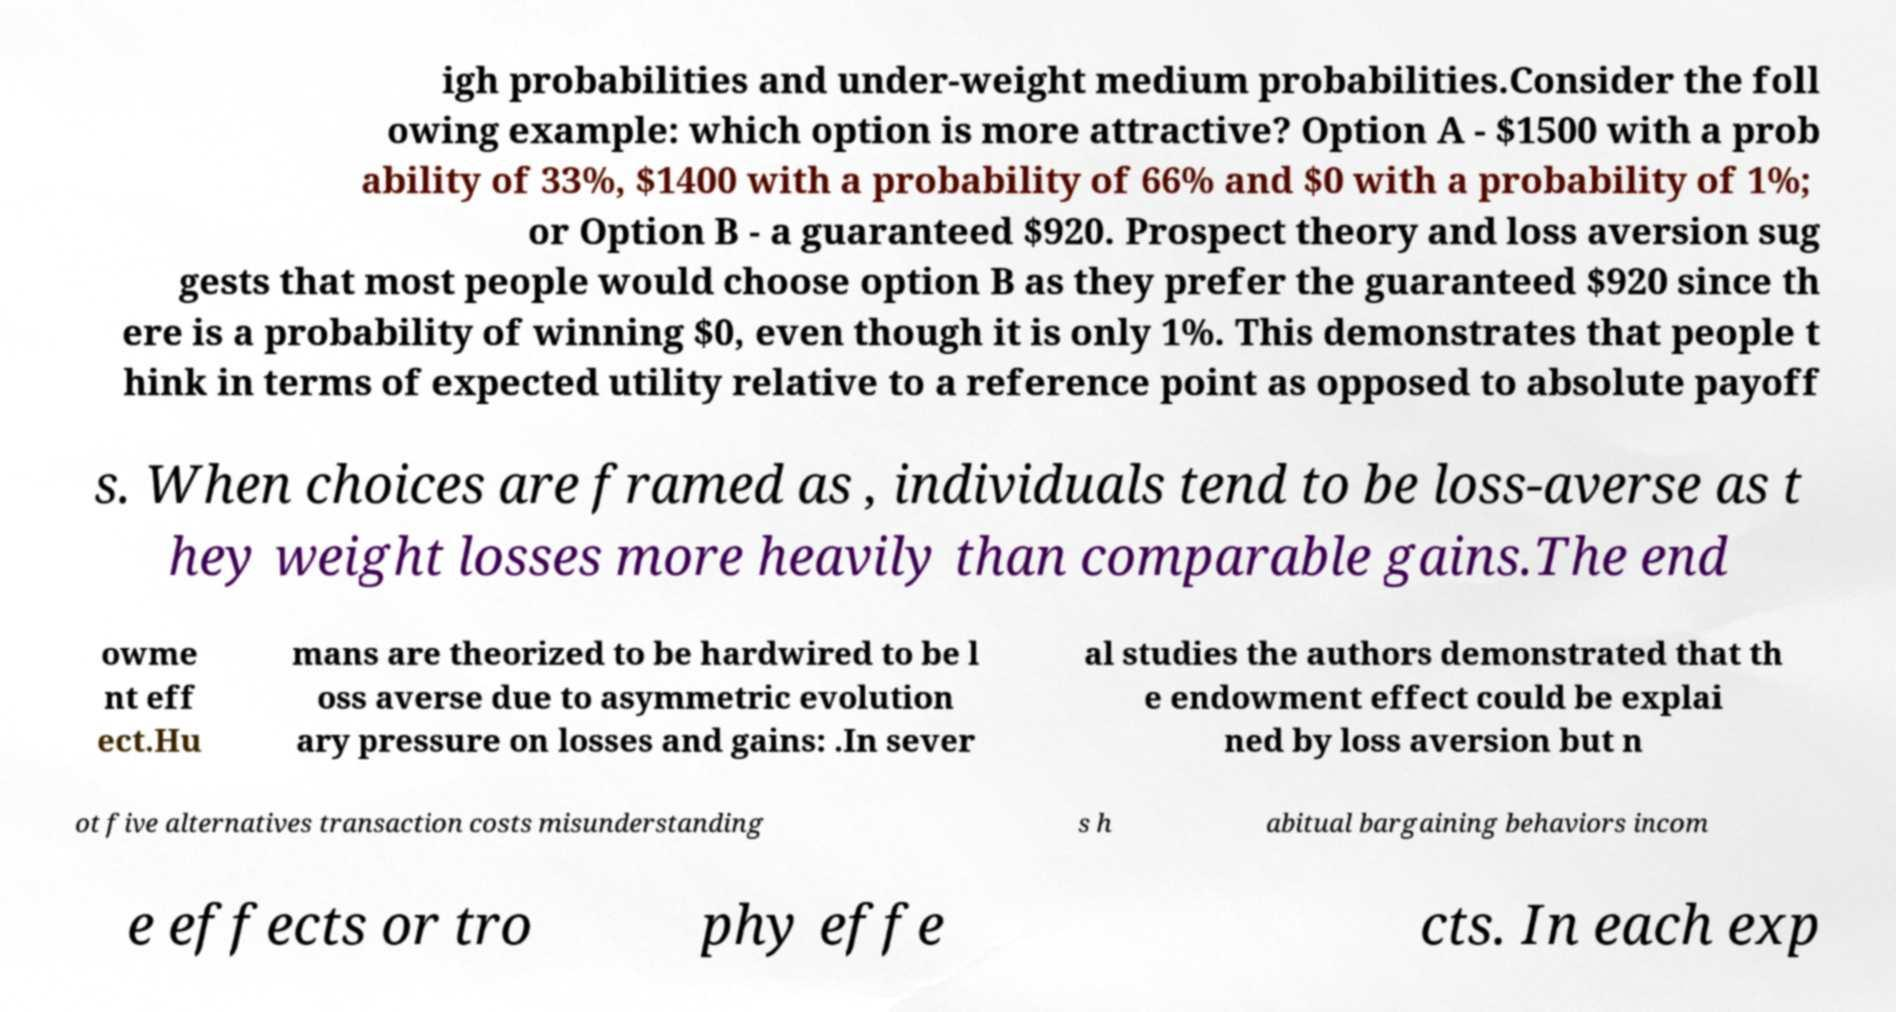Please identify and transcribe the text found in this image. igh probabilities and under-weight medium probabilities.Consider the foll owing example: which option is more attractive? Option A - $1500 with a prob ability of 33%, $1400 with a probability of 66% and $0 with a probability of 1%; or Option B - a guaranteed $920. Prospect theory and loss aversion sug gests that most people would choose option B as they prefer the guaranteed $920 since th ere is a probability of winning $0, even though it is only 1%. This demonstrates that people t hink in terms of expected utility relative to a reference point as opposed to absolute payoff s. When choices are framed as , individuals tend to be loss-averse as t hey weight losses more heavily than comparable gains.The end owme nt eff ect.Hu mans are theorized to be hardwired to be l oss averse due to asymmetric evolution ary pressure on losses and gains: .In sever al studies the authors demonstrated that th e endowment effect could be explai ned by loss aversion but n ot five alternatives transaction costs misunderstanding s h abitual bargaining behaviors incom e effects or tro phy effe cts. In each exp 